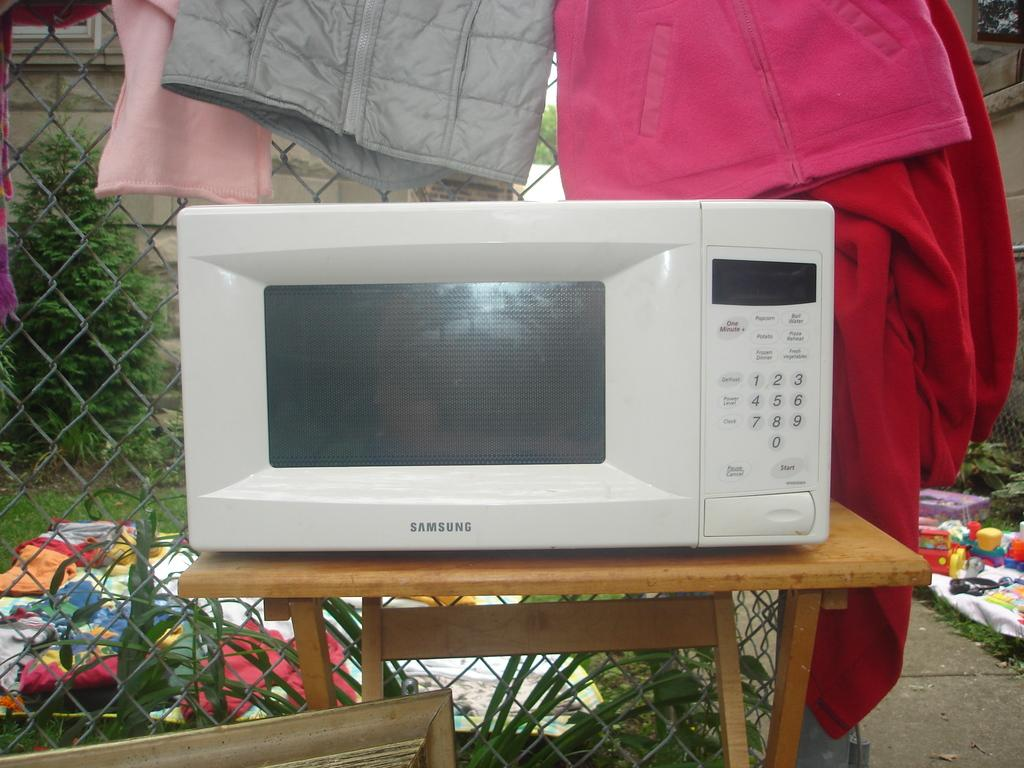<image>
Provide a brief description of the given image. A Samsung microwave sits on a table outdoors. 